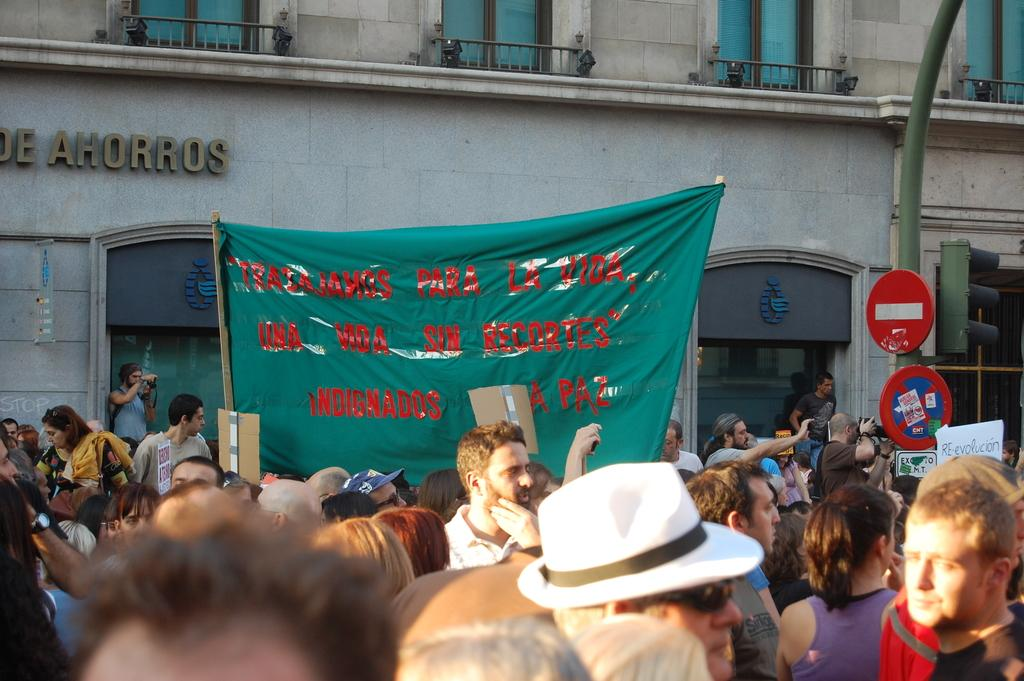What can be seen in the background of the image? There is a building in the background of the image. How many people are visible at the bottom of the image? There are many people at the bottom of the image. What is present in the image that provides information or directions? There is a sign board in the image. What device is used to control traffic in the image? There is a traffic signal in the image. Can you see someone's thumb in the image? There is no thumb visible in the image. What type of drink is being served at the protest in the image? There is no protest or drink present in the image. 